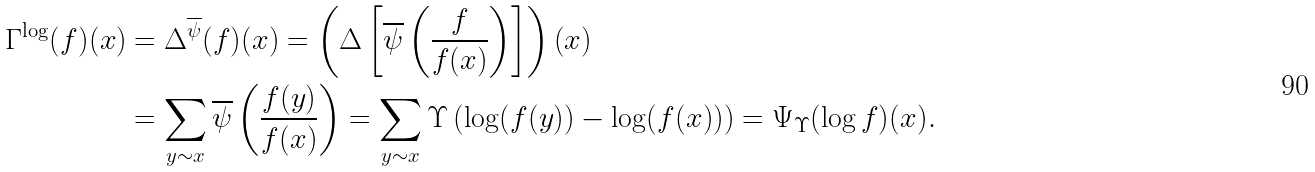Convert formula to latex. <formula><loc_0><loc_0><loc_500><loc_500>\Gamma ^ { \log } ( f ) ( x ) & = \Delta ^ { \overline { \psi } } ( f ) ( x ) = \left ( \Delta \left [ \overline { \psi } \left ( \frac { f } { f ( x ) } \right ) \right ] \right ) \left ( x \right ) \\ & = \sum _ { y \sim x } \overline { \psi } \left ( \frac { f ( y ) } { f ( x ) } \right ) = \sum _ { y \sim x } \Upsilon \left ( \log ( f ( y ) ) - \log ( f ( x ) ) \right ) = \Psi _ { \Upsilon } ( \log f ) ( x ) .</formula> 